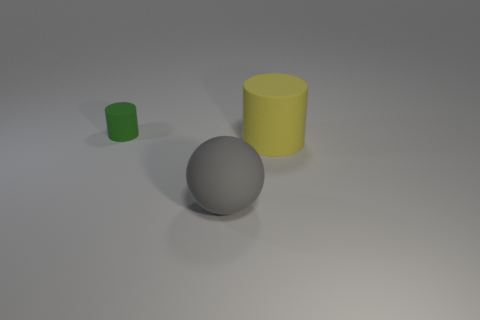There is a large yellow object; what number of big objects are left of it?
Your answer should be compact. 1. The cylinder behind the cylinder that is to the right of the gray rubber object is made of what material?
Your answer should be compact. Rubber. Are there any other things that have the same size as the green object?
Your answer should be compact. No. Do the gray thing and the yellow matte thing have the same size?
Keep it short and to the point. Yes. How many things are objects in front of the tiny cylinder or things on the left side of the big gray matte object?
Provide a short and direct response. 3. Is the number of cylinders that are on the right side of the small green cylinder greater than the number of purple matte cylinders?
Provide a succinct answer. Yes. How many other things are there of the same shape as the yellow matte thing?
Offer a terse response. 1. The thing that is behind the matte ball and right of the small green thing is made of what material?
Make the answer very short. Rubber. What number of things are either small brown cylinders or large yellow cylinders?
Give a very brief answer. 1. Are there more cylinders than small green metallic blocks?
Offer a terse response. Yes. 